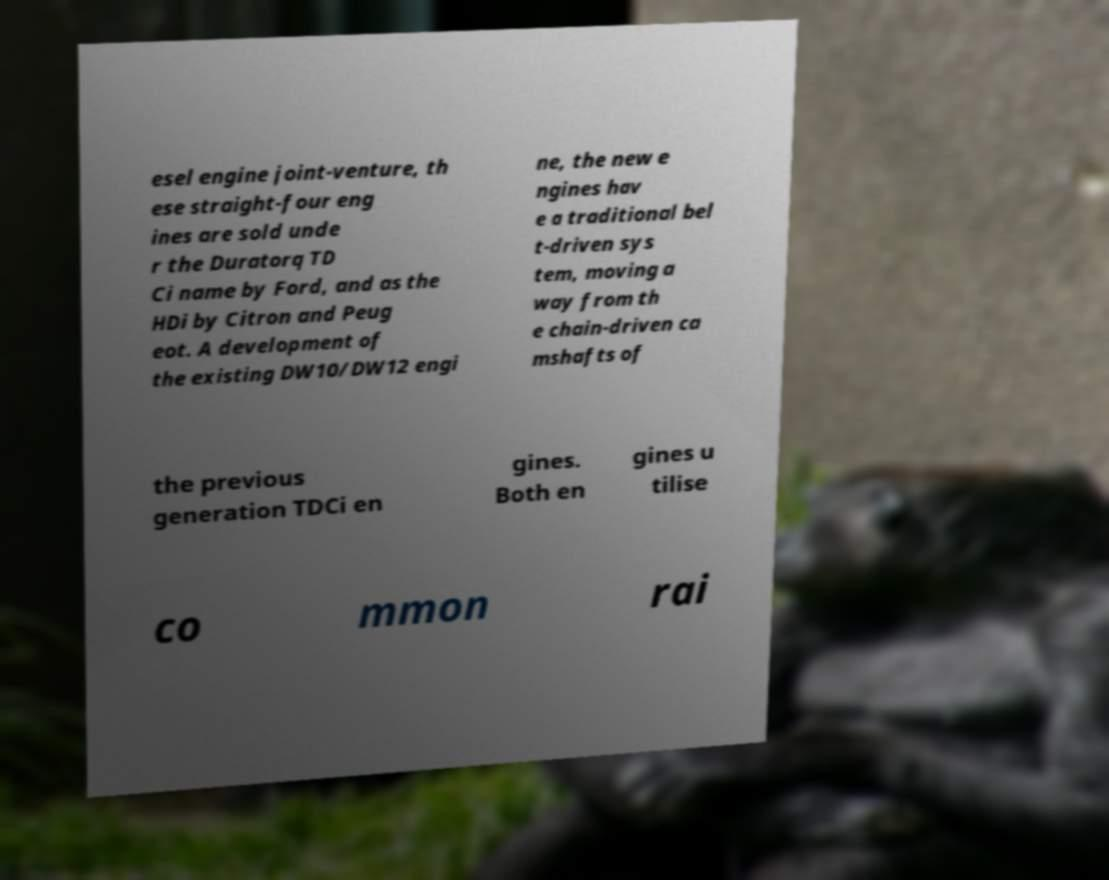Could you extract and type out the text from this image? esel engine joint-venture, th ese straight-four eng ines are sold unde r the Duratorq TD Ci name by Ford, and as the HDi by Citron and Peug eot. A development of the existing DW10/DW12 engi ne, the new e ngines hav e a traditional bel t-driven sys tem, moving a way from th e chain-driven ca mshafts of the previous generation TDCi en gines. Both en gines u tilise co mmon rai 